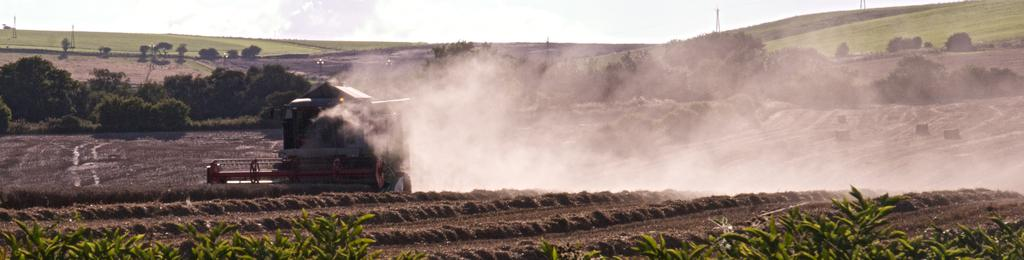What is located on the ground in the image? There is a vehicle on the ground in the image. What type of natural environment can be seen in the image? Fields, trees, and plants are present in the image, indicating a natural environment. What structures are visible in the image? Poles are visible in the image. What is the source of the smoke in the image? The source of the smoke is not specified in the image. What is visible at the top of the image? The sky is visible at the top of the image. What type of cherry is being used to sort the mint in the image? There is no cherry or mint present in the image, and therefore no such activity can be observed. 